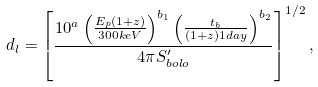<formula> <loc_0><loc_0><loc_500><loc_500>d _ { l } = \left [ \frac { 1 0 ^ { a } \left ( \frac { E _ { p } ( 1 + z ) } { 3 0 0 k e V } \right ) ^ { b _ { 1 } } \left ( \frac { t _ { b } } { ( 1 + z ) 1 d a y } \right ) ^ { b _ { 2 } } } { 4 \pi S ^ { \prime } _ { b o l o } } \right ] ^ { 1 / 2 } ,</formula> 